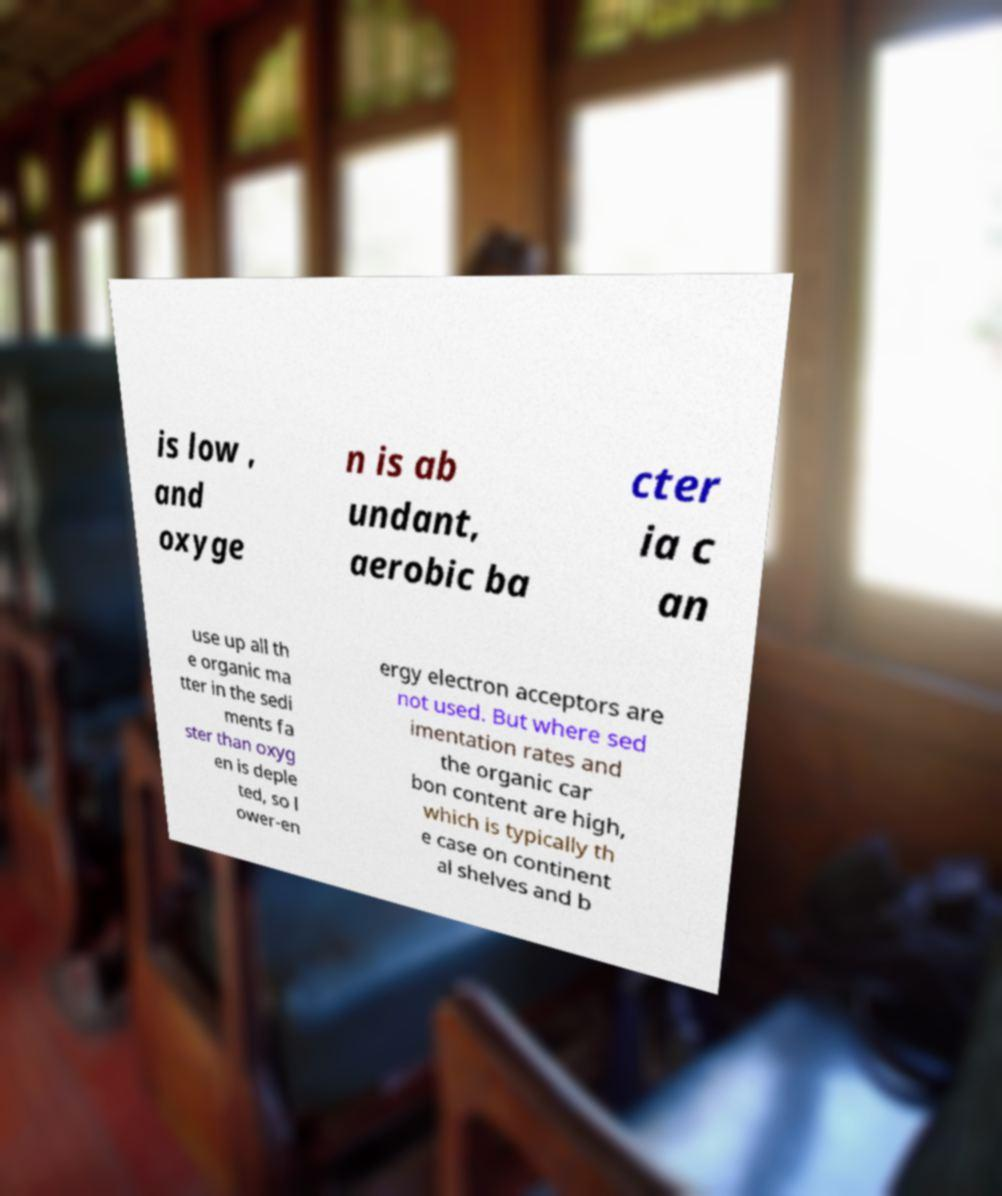For documentation purposes, I need the text within this image transcribed. Could you provide that? is low , and oxyge n is ab undant, aerobic ba cter ia c an use up all th e organic ma tter in the sedi ments fa ster than oxyg en is deple ted, so l ower-en ergy electron acceptors are not used. But where sed imentation rates and the organic car bon content are high, which is typically th e case on continent al shelves and b 